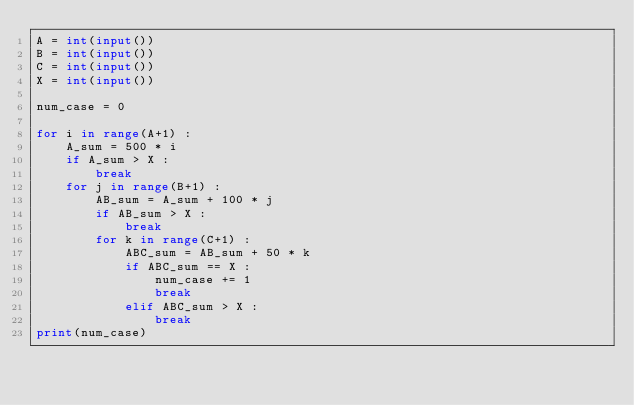Convert code to text. <code><loc_0><loc_0><loc_500><loc_500><_Python_>A = int(input())
B = int(input())
C = int(input())
X = int(input())

num_case = 0

for i in range(A+1) :
	A_sum = 500 * i
	if A_sum > X :
		break
	for j in range(B+1) :
		AB_sum = A_sum + 100 * j
		if AB_sum > X :
			break
		for k in range(C+1) :
			ABC_sum = AB_sum + 50 * k
			if ABC_sum == X :
				num_case += 1
				break
			elif ABC_sum > X :
				break
print(num_case)</code> 